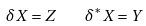Convert formula to latex. <formula><loc_0><loc_0><loc_500><loc_500>\delta X = Z \quad \delta ^ { * } X = Y</formula> 